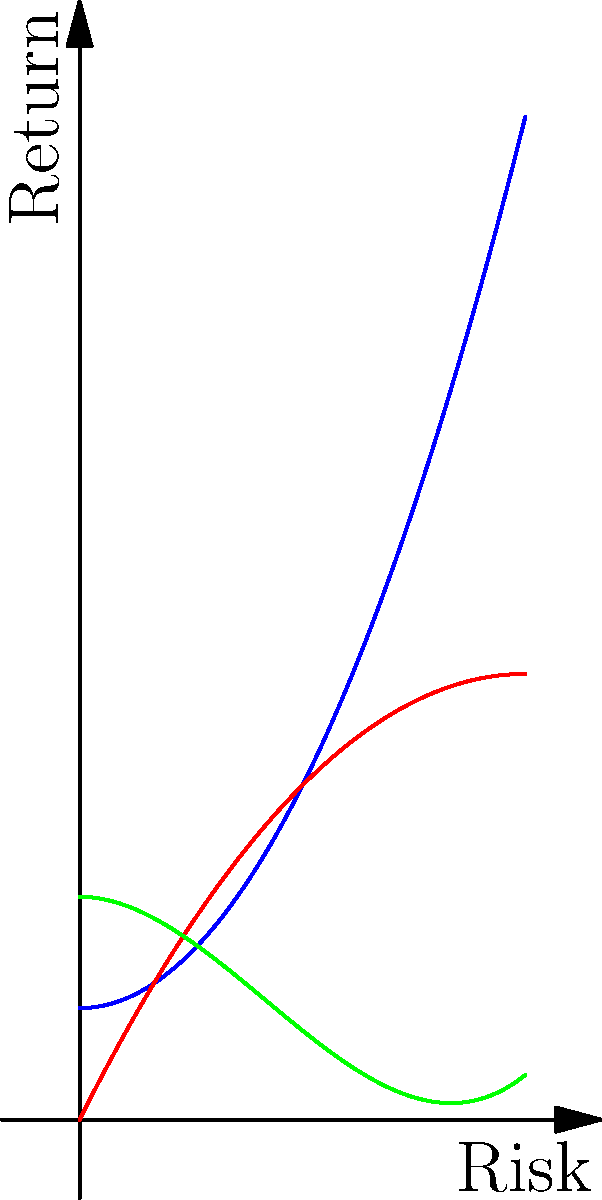Given the polynomial risk-return curves for three different asset classes (A, B, and C) as shown in the graph, which asset or combination of assets would you recommend for optimizing the portfolio allocation if the tycoon's risk tolerance is moderate (around 2 on the risk scale)? To determine the optimal portfolio allocation, we need to analyze the risk-return characteristics of each asset at the given risk level:

1. Identify the risk level: The tycoon has a moderate risk tolerance, around 2 on the risk scale.

2. Evaluate each asset at x = 2 (risk level):
   Asset A: $f_A(x) = 0.5x^2 + 1$
   At x = 2: $f_A(2) = 0.5(2)^2 + 1 = 3$

   Asset B: $f_B(x) = -0.25x^2 + 2x$
   At x = 2: $f_B(2) = -0.25(2)^2 + 2(2) = 3$

   Asset C: $f_C(x) = 0.1x^3 - 0.5x^2 + 2$
   At x = 2: $f_C(2) = 0.1(2)^3 - 0.5(2)^2 + 2 = 1.8$

3. Compare the returns:
   Assets A and B offer the same return (3) at the given risk level, while Asset C offers a lower return (1.8).

4. Consider the curve shapes:
   Asset A has an increasing slope, indicating higher potential returns but also higher risk as the risk level increases.
   Asset B has a decreasing slope, suggesting diminishing returns as risk increases.
   Asset C has a more complex curve, with potentially higher returns at higher risk levels.

5. Optimal allocation:
   For a moderate risk tolerance, a combination of Assets A and B would be optimal. This allows for diversification while maximizing returns at the given risk level.
Answer: Combination of Assets A and B 